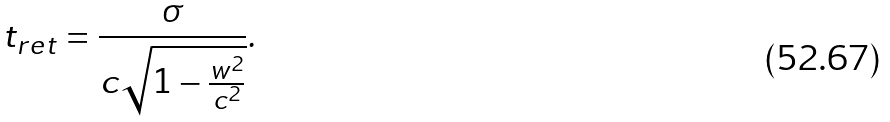<formula> <loc_0><loc_0><loc_500><loc_500>t _ { r e t } = \frac { \sigma } { c \sqrt { 1 - \frac { w ^ { 2 } } { c ^ { 2 } } } } .</formula> 